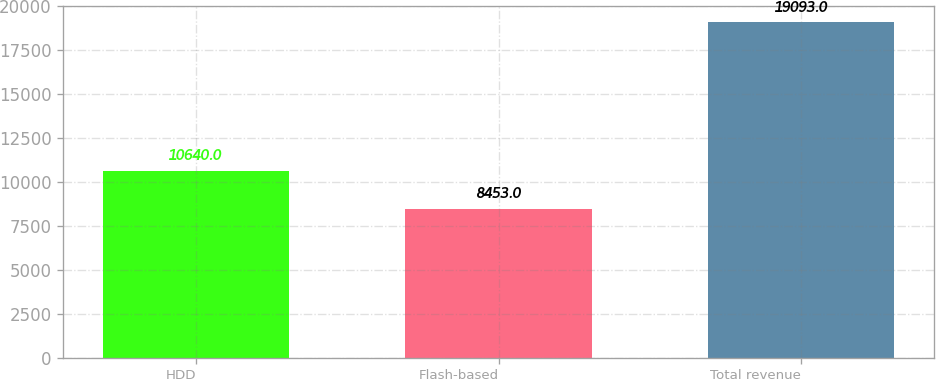Convert chart to OTSL. <chart><loc_0><loc_0><loc_500><loc_500><bar_chart><fcel>HDD<fcel>Flash-based<fcel>Total revenue<nl><fcel>10640<fcel>8453<fcel>19093<nl></chart> 